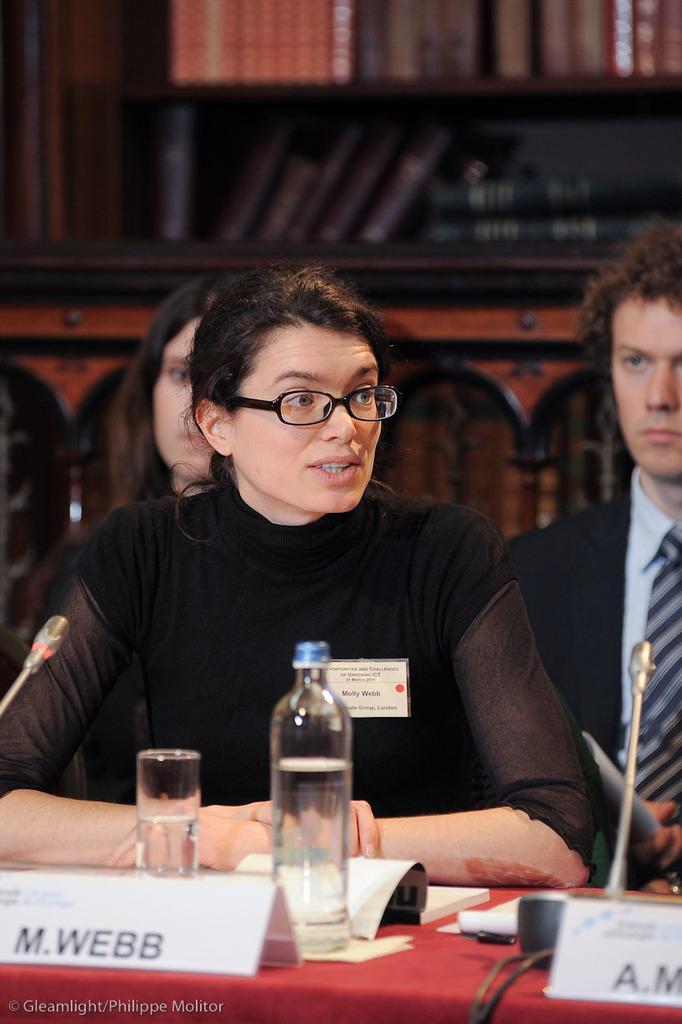How would you summarize this image in a sentence or two? In this picture we can see some persons sitting on the chairs. This is table. On the table there are bottle, glass, and book. On the background there is a rack. 